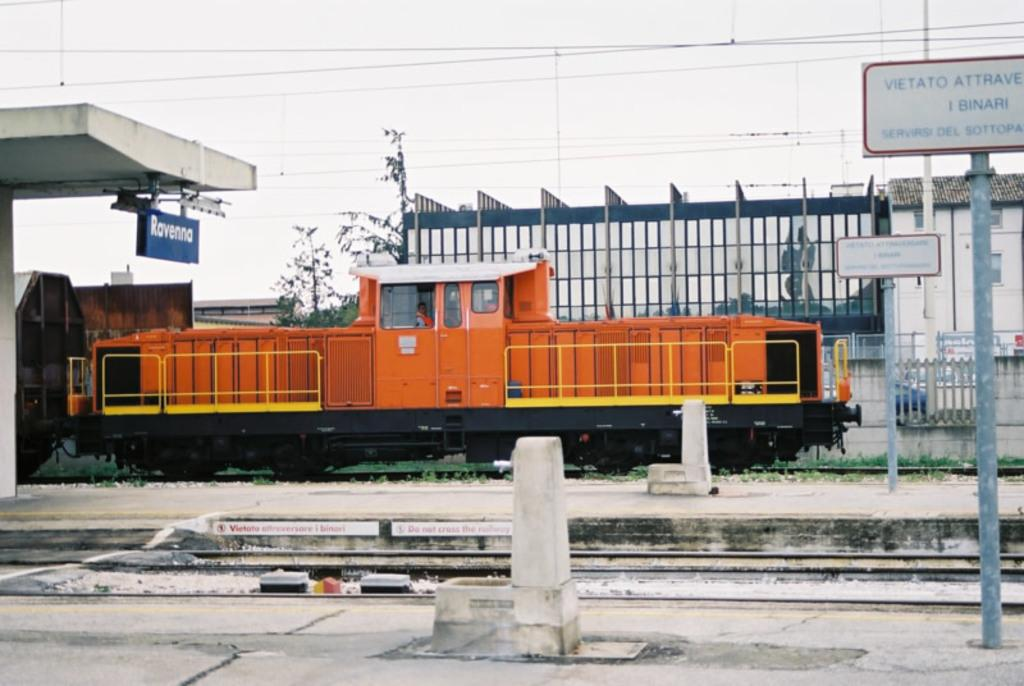<image>
Offer a succinct explanation of the picture presented. A train caboose in the background, a sign in the foreground that says Vietato Attrave. 